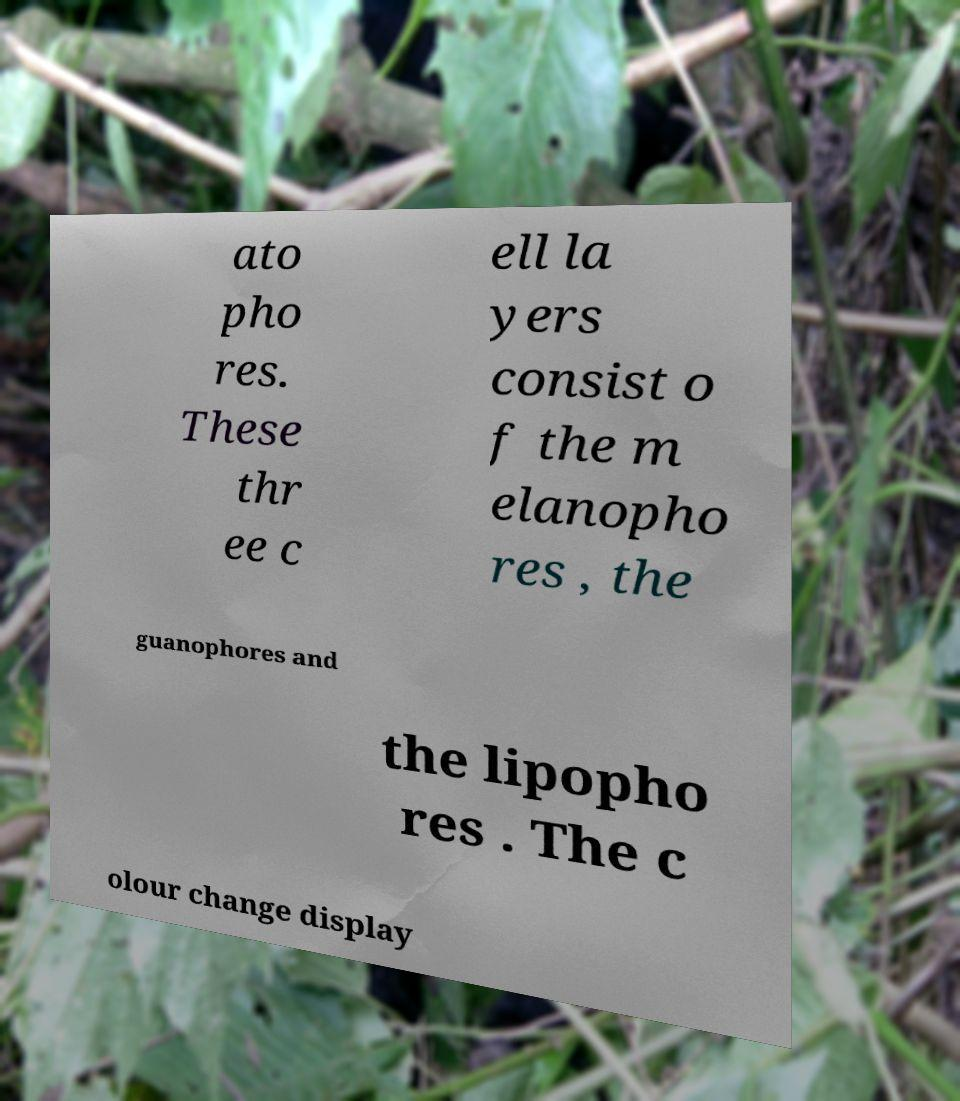Could you extract and type out the text from this image? ato pho res. These thr ee c ell la yers consist o f the m elanopho res , the guanophores and the lipopho res . The c olour change display 